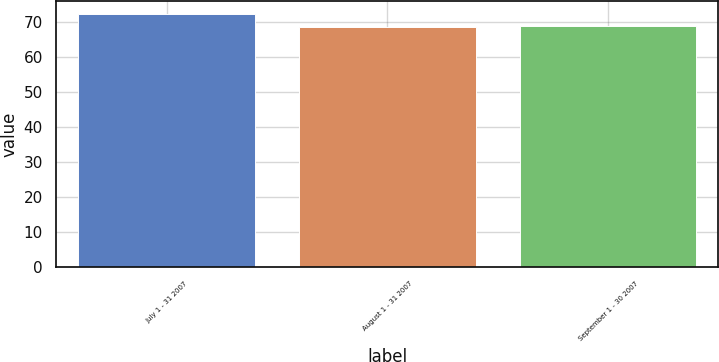Convert chart. <chart><loc_0><loc_0><loc_500><loc_500><bar_chart><fcel>July 1 - 31 2007<fcel>August 1 - 31 2007<fcel>September 1 - 30 2007<nl><fcel>72.33<fcel>68.56<fcel>68.94<nl></chart> 